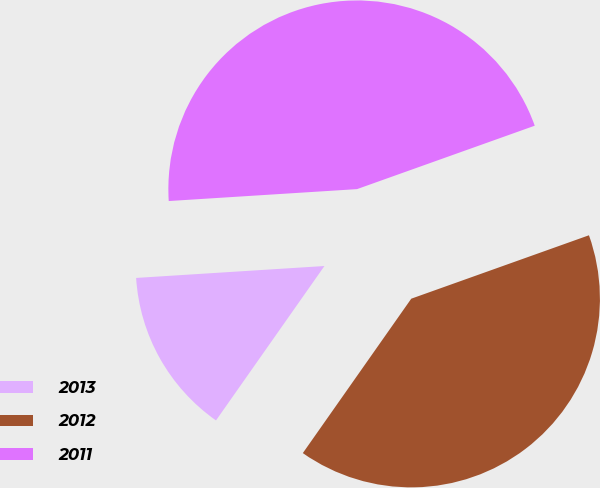<chart> <loc_0><loc_0><loc_500><loc_500><pie_chart><fcel>2013<fcel>2012<fcel>2011<nl><fcel>14.25%<fcel>40.2%<fcel>45.55%<nl></chart> 